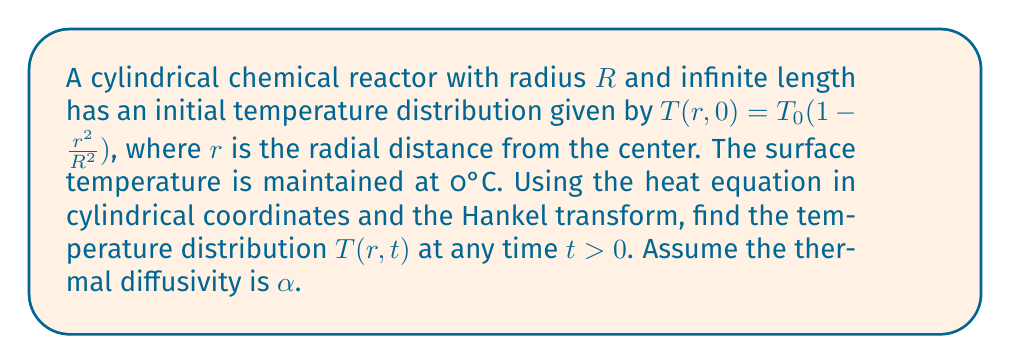Can you solve this math problem? 1) The heat equation in cylindrical coordinates for this problem is:

   $$\frac{\partial T}{\partial t} = \alpha \left(\frac{\partial^2 T}{\partial r^2} + \frac{1}{r}\frac{\partial T}{\partial r}\right)$$

2) Apply the Hankel transform of order 0 to both sides:

   $$\frac{\partial \bar{T}}{\partial t} = -\alpha \xi^2 \bar{T}$$

   where $\bar{T}(\xi,t)$ is the Hankel transform of $T(r,t)$ and $\xi$ is the transform variable.

3) Solve this ordinary differential equation:

   $$\bar{T}(\xi,t) = \bar{T}(\xi,0)e^{-\alpha\xi^2t}$$

4) The initial condition in Hankel space is:

   $$\bar{T}(\xi,0) = \int_0^R T_0\left(1 - \frac{r^2}{R^2}\right)rJ_0(\xi r)dr$$

   $$= \frac{2T_0}{\xi R}J_1(\xi R)$$

5) Therefore, the solution in Hankel space is:

   $$\bar{T}(\xi,t) = \frac{2T_0}{\xi R}J_1(\xi R)e^{-\alpha\xi^2t}$$

6) Apply the inverse Hankel transform:

   $$T(r,t) = \int_0^\infty \xi \bar{T}(\xi,t)J_0(\xi r)d\xi$$

   $$= \frac{2T_0}{R}\int_0^\infty J_1(\xi R)J_0(\xi r)e^{-\alpha\xi^2t}d\xi$$

7) This integral can be evaluated using the identity:

   $$\int_0^\infty J_1(\xi R)J_0(\xi r)e^{-\alpha\xi^2t}d\xi = \frac{r}{2\alpha t R}e^{-\frac{r^2+R^2}{4\alpha t}}I_1\left(\frac{rR}{2\alpha t}\right)$$

   where $I_1$ is the modified Bessel function of the first kind.

8) The final solution is:

   $$T(r,t) = \frac{T_0r}{\alpha t R^2}e^{-\frac{r^2+R^2}{4\alpha t}}I_1\left(\frac{rR}{2\alpha t}\right)$$
Answer: $T(r,t) = \frac{T_0r}{\alpha t R^2}e^{-\frac{r^2+R^2}{4\alpha t}}I_1\left(\frac{rR}{2\alpha t}\right)$ 